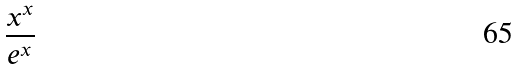Convert formula to latex. <formula><loc_0><loc_0><loc_500><loc_500>\frac { x ^ { x } } { e ^ { x } }</formula> 